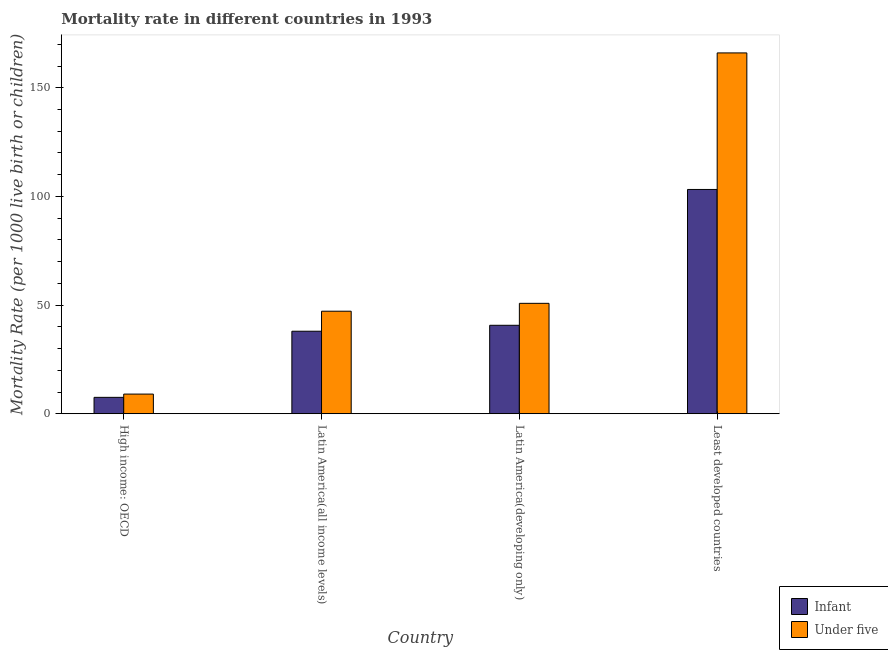Are the number of bars per tick equal to the number of legend labels?
Offer a very short reply. Yes. What is the label of the 2nd group of bars from the left?
Ensure brevity in your answer.  Latin America(all income levels). What is the under-5 mortality rate in High income: OECD?
Give a very brief answer. 9.04. Across all countries, what is the maximum under-5 mortality rate?
Provide a succinct answer. 166.02. Across all countries, what is the minimum infant mortality rate?
Provide a short and direct response. 7.54. In which country was the under-5 mortality rate maximum?
Your response must be concise. Least developed countries. In which country was the infant mortality rate minimum?
Keep it short and to the point. High income: OECD. What is the total under-5 mortality rate in the graph?
Provide a succinct answer. 273.04. What is the difference between the infant mortality rate in Latin America(developing only) and that in Least developed countries?
Give a very brief answer. -62.49. What is the difference between the infant mortality rate in Latin America(all income levels) and the under-5 mortality rate in Latin America(developing only)?
Your response must be concise. -12.83. What is the average under-5 mortality rate per country?
Ensure brevity in your answer.  68.26. What is the difference between the infant mortality rate and under-5 mortality rate in High income: OECD?
Provide a short and direct response. -1.5. What is the ratio of the infant mortality rate in High income: OECD to that in Latin America(developing only)?
Provide a succinct answer. 0.19. Is the infant mortality rate in High income: OECD less than that in Latin America(all income levels)?
Offer a terse response. Yes. Is the difference between the under-5 mortality rate in High income: OECD and Latin America(developing only) greater than the difference between the infant mortality rate in High income: OECD and Latin America(developing only)?
Ensure brevity in your answer.  No. What is the difference between the highest and the second highest infant mortality rate?
Offer a terse response. 62.49. What is the difference between the highest and the lowest under-5 mortality rate?
Your response must be concise. 156.98. Is the sum of the under-5 mortality rate in High income: OECD and Latin America(developing only) greater than the maximum infant mortality rate across all countries?
Your answer should be very brief. No. What does the 2nd bar from the left in Latin America(developing only) represents?
Offer a very short reply. Under five. What does the 2nd bar from the right in Latin America(developing only) represents?
Your answer should be compact. Infant. How many bars are there?
Your response must be concise. 8. Are all the bars in the graph horizontal?
Offer a very short reply. No. Are the values on the major ticks of Y-axis written in scientific E-notation?
Your answer should be very brief. No. Does the graph contain any zero values?
Provide a succinct answer. No. How many legend labels are there?
Give a very brief answer. 2. How are the legend labels stacked?
Offer a terse response. Vertical. What is the title of the graph?
Ensure brevity in your answer.  Mortality rate in different countries in 1993. Does "% of gross capital formation" appear as one of the legend labels in the graph?
Keep it short and to the point. No. What is the label or title of the X-axis?
Provide a short and direct response. Country. What is the label or title of the Y-axis?
Ensure brevity in your answer.  Mortality Rate (per 1000 live birth or children). What is the Mortality Rate (per 1000 live birth or children) in Infant in High income: OECD?
Give a very brief answer. 7.54. What is the Mortality Rate (per 1000 live birth or children) in Under five in High income: OECD?
Provide a succinct answer. 9.04. What is the Mortality Rate (per 1000 live birth or children) in Infant in Latin America(all income levels)?
Offer a terse response. 37.97. What is the Mortality Rate (per 1000 live birth or children) of Under five in Latin America(all income levels)?
Offer a very short reply. 47.18. What is the Mortality Rate (per 1000 live birth or children) in Infant in Latin America(developing only)?
Give a very brief answer. 40.7. What is the Mortality Rate (per 1000 live birth or children) in Under five in Latin America(developing only)?
Make the answer very short. 50.8. What is the Mortality Rate (per 1000 live birth or children) in Infant in Least developed countries?
Keep it short and to the point. 103.19. What is the Mortality Rate (per 1000 live birth or children) of Under five in Least developed countries?
Provide a succinct answer. 166.02. Across all countries, what is the maximum Mortality Rate (per 1000 live birth or children) in Infant?
Give a very brief answer. 103.19. Across all countries, what is the maximum Mortality Rate (per 1000 live birth or children) in Under five?
Your response must be concise. 166.02. Across all countries, what is the minimum Mortality Rate (per 1000 live birth or children) in Infant?
Give a very brief answer. 7.54. Across all countries, what is the minimum Mortality Rate (per 1000 live birth or children) in Under five?
Your answer should be compact. 9.04. What is the total Mortality Rate (per 1000 live birth or children) in Infant in the graph?
Keep it short and to the point. 189.4. What is the total Mortality Rate (per 1000 live birth or children) in Under five in the graph?
Keep it short and to the point. 273.04. What is the difference between the Mortality Rate (per 1000 live birth or children) in Infant in High income: OECD and that in Latin America(all income levels)?
Ensure brevity in your answer.  -30.42. What is the difference between the Mortality Rate (per 1000 live birth or children) of Under five in High income: OECD and that in Latin America(all income levels)?
Make the answer very short. -38.14. What is the difference between the Mortality Rate (per 1000 live birth or children) of Infant in High income: OECD and that in Latin America(developing only)?
Provide a short and direct response. -33.16. What is the difference between the Mortality Rate (per 1000 live birth or children) of Under five in High income: OECD and that in Latin America(developing only)?
Offer a very short reply. -41.76. What is the difference between the Mortality Rate (per 1000 live birth or children) of Infant in High income: OECD and that in Least developed countries?
Offer a terse response. -95.65. What is the difference between the Mortality Rate (per 1000 live birth or children) of Under five in High income: OECD and that in Least developed countries?
Make the answer very short. -156.98. What is the difference between the Mortality Rate (per 1000 live birth or children) in Infant in Latin America(all income levels) and that in Latin America(developing only)?
Provide a short and direct response. -2.73. What is the difference between the Mortality Rate (per 1000 live birth or children) of Under five in Latin America(all income levels) and that in Latin America(developing only)?
Your answer should be compact. -3.62. What is the difference between the Mortality Rate (per 1000 live birth or children) in Infant in Latin America(all income levels) and that in Least developed countries?
Make the answer very short. -65.23. What is the difference between the Mortality Rate (per 1000 live birth or children) in Under five in Latin America(all income levels) and that in Least developed countries?
Provide a short and direct response. -118.84. What is the difference between the Mortality Rate (per 1000 live birth or children) in Infant in Latin America(developing only) and that in Least developed countries?
Offer a terse response. -62.49. What is the difference between the Mortality Rate (per 1000 live birth or children) of Under five in Latin America(developing only) and that in Least developed countries?
Keep it short and to the point. -115.22. What is the difference between the Mortality Rate (per 1000 live birth or children) of Infant in High income: OECD and the Mortality Rate (per 1000 live birth or children) of Under five in Latin America(all income levels)?
Your answer should be compact. -39.63. What is the difference between the Mortality Rate (per 1000 live birth or children) of Infant in High income: OECD and the Mortality Rate (per 1000 live birth or children) of Under five in Latin America(developing only)?
Offer a very short reply. -43.26. What is the difference between the Mortality Rate (per 1000 live birth or children) in Infant in High income: OECD and the Mortality Rate (per 1000 live birth or children) in Under five in Least developed countries?
Your answer should be very brief. -158.48. What is the difference between the Mortality Rate (per 1000 live birth or children) in Infant in Latin America(all income levels) and the Mortality Rate (per 1000 live birth or children) in Under five in Latin America(developing only)?
Make the answer very short. -12.83. What is the difference between the Mortality Rate (per 1000 live birth or children) in Infant in Latin America(all income levels) and the Mortality Rate (per 1000 live birth or children) in Under five in Least developed countries?
Your response must be concise. -128.06. What is the difference between the Mortality Rate (per 1000 live birth or children) of Infant in Latin America(developing only) and the Mortality Rate (per 1000 live birth or children) of Under five in Least developed countries?
Give a very brief answer. -125.32. What is the average Mortality Rate (per 1000 live birth or children) of Infant per country?
Give a very brief answer. 47.35. What is the average Mortality Rate (per 1000 live birth or children) of Under five per country?
Your answer should be compact. 68.26. What is the difference between the Mortality Rate (per 1000 live birth or children) in Infant and Mortality Rate (per 1000 live birth or children) in Under five in High income: OECD?
Your answer should be very brief. -1.5. What is the difference between the Mortality Rate (per 1000 live birth or children) of Infant and Mortality Rate (per 1000 live birth or children) of Under five in Latin America(all income levels)?
Offer a terse response. -9.21. What is the difference between the Mortality Rate (per 1000 live birth or children) of Infant and Mortality Rate (per 1000 live birth or children) of Under five in Least developed countries?
Your answer should be compact. -62.83. What is the ratio of the Mortality Rate (per 1000 live birth or children) of Infant in High income: OECD to that in Latin America(all income levels)?
Give a very brief answer. 0.2. What is the ratio of the Mortality Rate (per 1000 live birth or children) in Under five in High income: OECD to that in Latin America(all income levels)?
Provide a succinct answer. 0.19. What is the ratio of the Mortality Rate (per 1000 live birth or children) in Infant in High income: OECD to that in Latin America(developing only)?
Keep it short and to the point. 0.19. What is the ratio of the Mortality Rate (per 1000 live birth or children) in Under five in High income: OECD to that in Latin America(developing only)?
Give a very brief answer. 0.18. What is the ratio of the Mortality Rate (per 1000 live birth or children) in Infant in High income: OECD to that in Least developed countries?
Offer a terse response. 0.07. What is the ratio of the Mortality Rate (per 1000 live birth or children) of Under five in High income: OECD to that in Least developed countries?
Make the answer very short. 0.05. What is the ratio of the Mortality Rate (per 1000 live birth or children) in Infant in Latin America(all income levels) to that in Latin America(developing only)?
Provide a succinct answer. 0.93. What is the ratio of the Mortality Rate (per 1000 live birth or children) of Under five in Latin America(all income levels) to that in Latin America(developing only)?
Make the answer very short. 0.93. What is the ratio of the Mortality Rate (per 1000 live birth or children) in Infant in Latin America(all income levels) to that in Least developed countries?
Your response must be concise. 0.37. What is the ratio of the Mortality Rate (per 1000 live birth or children) in Under five in Latin America(all income levels) to that in Least developed countries?
Offer a very short reply. 0.28. What is the ratio of the Mortality Rate (per 1000 live birth or children) of Infant in Latin America(developing only) to that in Least developed countries?
Keep it short and to the point. 0.39. What is the ratio of the Mortality Rate (per 1000 live birth or children) of Under five in Latin America(developing only) to that in Least developed countries?
Offer a very short reply. 0.31. What is the difference between the highest and the second highest Mortality Rate (per 1000 live birth or children) of Infant?
Your answer should be very brief. 62.49. What is the difference between the highest and the second highest Mortality Rate (per 1000 live birth or children) of Under five?
Ensure brevity in your answer.  115.22. What is the difference between the highest and the lowest Mortality Rate (per 1000 live birth or children) of Infant?
Your answer should be compact. 95.65. What is the difference between the highest and the lowest Mortality Rate (per 1000 live birth or children) in Under five?
Offer a very short reply. 156.98. 